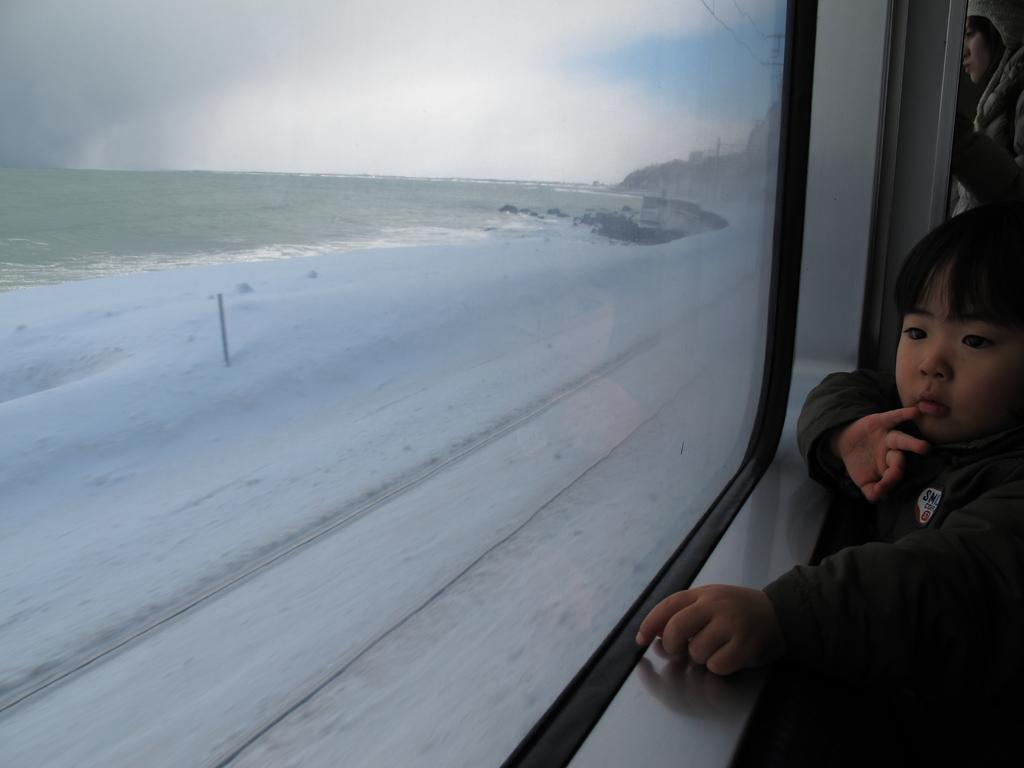What is the vantage point of the image? The image is taken from a train. What can be seen on the right side of the image? There is a kid on the right side of the image. What object is present in the foreground of the image? There is a mirror in the foreground of the image. What is visible outside the mirror? Snow and a field are visible outside the mirror. How would you describe the weather based on the image? The sky is cloudy at the top of the image, suggesting a cloudy or overcast day. Who won the competition between the sister and the kid in the image? There is no competition or sister present in the image. What surprise is the kid holding in the image? There is no surprise visible in the image; the kid is simply standing on the right side. 